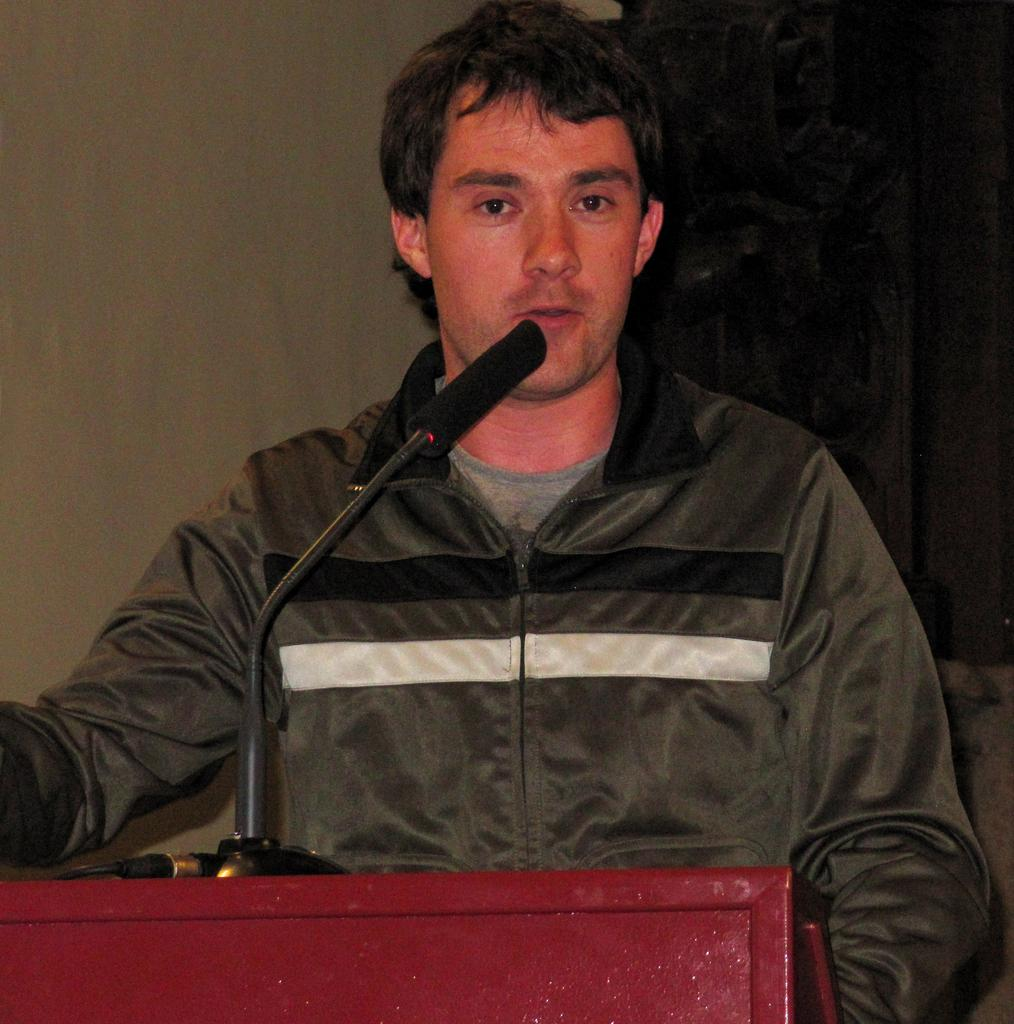Who or what is the main subject in the image? There is a person in the image. What is the person doing or standing near in the image? The person is standing near a podium. What type of clothing is the person wearing in the image? The person is wearing a jacket. What can be seen in the background of the image? There is a wall in the background of the image. How many dogs are visible in the image? There are no dogs present in the image. What type of chalk is the person using to write on the wall in the image? There is no chalk or writing on the wall in the image. 